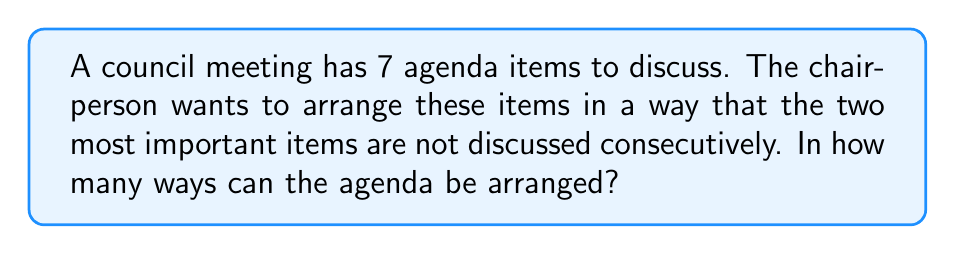Help me with this question. Let's approach this step-by-step:

1) First, we need to calculate the total number of ways to arrange 7 items:
   $$7! = 7 \times 6 \times 5 \times 4 \times 3 \times 2 \times 1 = 5040$$

2) Now, we need to subtract the number of arrangements where the two most important items are consecutive.

3) To count these arrangements:
   a) Consider the two most important items as one unit. Now we have 6 units to arrange (the unit of two items and the other 5 items).
   b) The number of ways to arrange 6 units is $6! = 720$.
   c) The two items within the unit can be arranged in 2! = 2 ways.

4) So, the number of arrangements with the two most important items consecutive is:
   $$6! \times 2! = 720 \times 2 = 1440$$

5) Therefore, the number of valid arrangements is:
   $$7! - (6! \times 2!) = 5040 - 1440 = 3600$$
Answer: 3600 